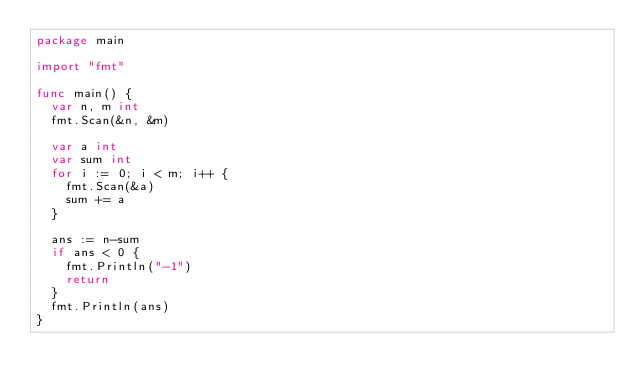Convert code to text. <code><loc_0><loc_0><loc_500><loc_500><_Go_>package main

import "fmt"

func main() {
	var n, m int
	fmt.Scan(&n, &m)

	var a int
	var sum int
	for i := 0; i < m; i++ {
		fmt.Scan(&a)
		sum += a
	}

	ans := n-sum
	if ans < 0 {
		fmt.Println("-1")
		return
	}
	fmt.Println(ans)
}
</code> 